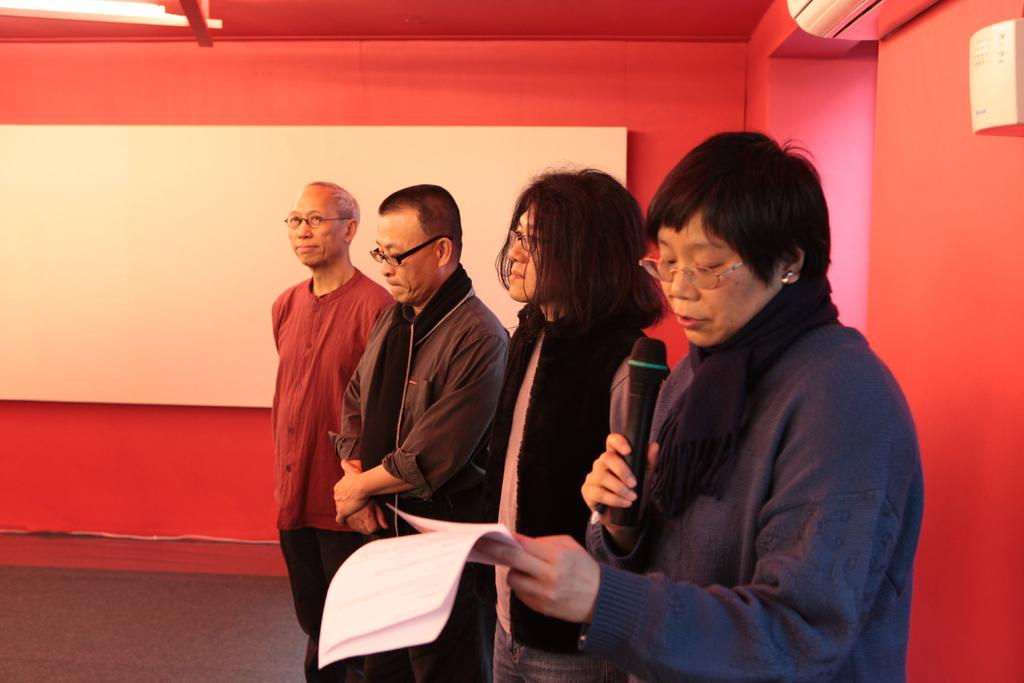What is happening in the image? There are people standing in the image. Can you describe the lady in the image? The lady is holding a microphone and papers in her hand. What can be seen in the background of the image? There are walls visible in the background of the image. What type of copper material is the lady using to hold the microphone? The lady is not using any copper material to hold the microphone; she is simply holding it. Can you see a zebra in the image? No, there is no zebra present in the image. 